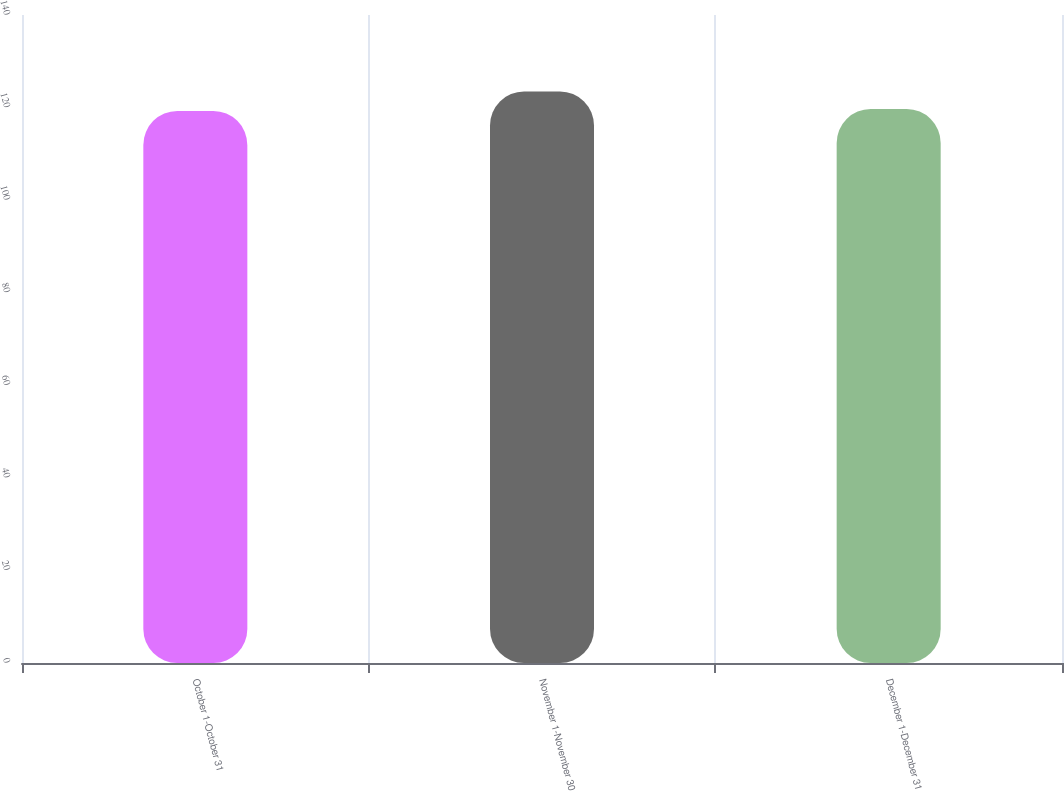Convert chart to OTSL. <chart><loc_0><loc_0><loc_500><loc_500><bar_chart><fcel>October 1-October 31<fcel>November 1-November 30<fcel>December 1-December 31<nl><fcel>119.28<fcel>123.47<fcel>119.7<nl></chart> 